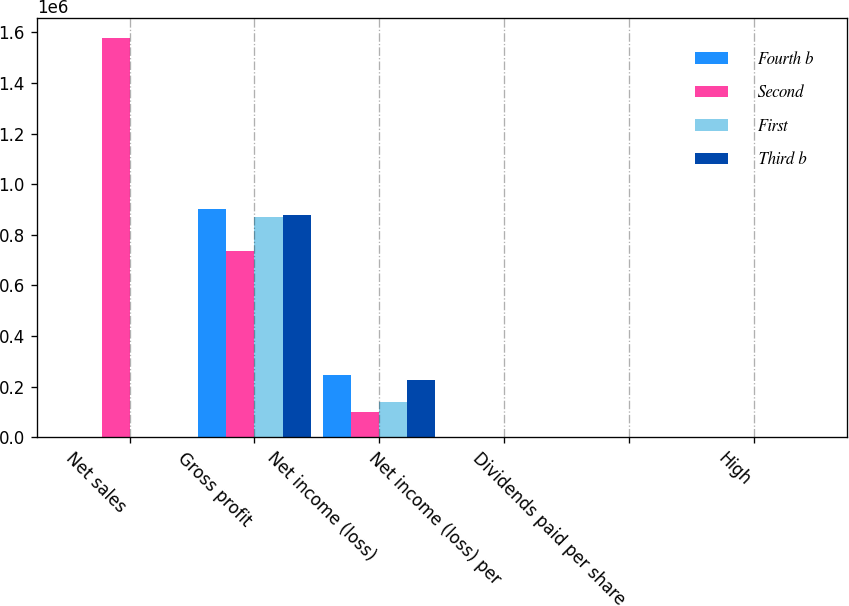Convert chart. <chart><loc_0><loc_0><loc_500><loc_500><stacked_bar_chart><ecel><fcel>Net sales<fcel>Gross profit<fcel>Net income (loss)<fcel>Net income (loss) per<fcel>Dividends paid per share<fcel>High<nl><fcel>Fourth b<fcel>1.1<fcel>900843<fcel>244737<fcel>1.03<fcel>0.54<fcel>110.78<nl><fcel>Second<fcel>1.57882e+06<fcel>735408<fcel>99941<fcel>0.42<fcel>0.54<fcel>101.74<nl><fcel>First<fcel>1.1<fcel>868706<fcel>140266<fcel>0.6<fcel>0.58<fcel>94.31<nl><fcel>Third b<fcel>1.1<fcel>877718<fcel>227889<fcel>0.98<fcel>0.58<fcel>97.07<nl></chart> 